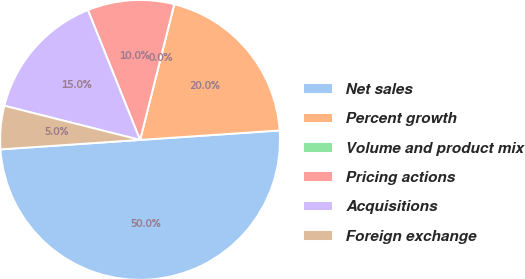Convert chart to OTSL. <chart><loc_0><loc_0><loc_500><loc_500><pie_chart><fcel>Net sales<fcel>Percent growth<fcel>Volume and product mix<fcel>Pricing actions<fcel>Acquisitions<fcel>Foreign exchange<nl><fcel>50.0%<fcel>20.0%<fcel>0.0%<fcel>10.0%<fcel>15.0%<fcel>5.0%<nl></chart> 